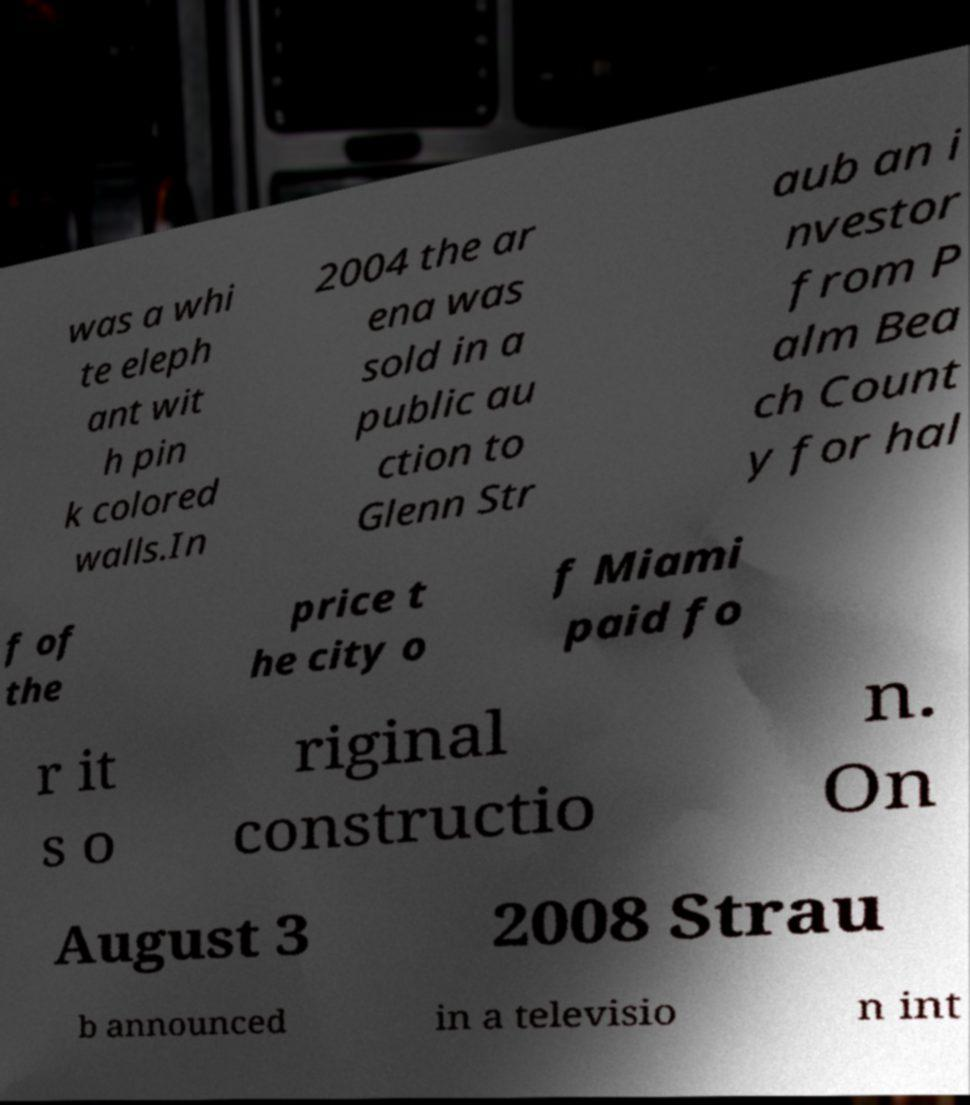For documentation purposes, I need the text within this image transcribed. Could you provide that? was a whi te eleph ant wit h pin k colored walls.In 2004 the ar ena was sold in a public au ction to Glenn Str aub an i nvestor from P alm Bea ch Count y for hal f of the price t he city o f Miami paid fo r it s o riginal constructio n. On August 3 2008 Strau b announced in a televisio n int 